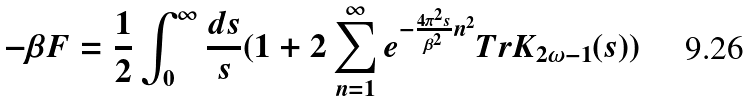Convert formula to latex. <formula><loc_0><loc_0><loc_500><loc_500>- \beta F = { \frac { 1 } { 2 } } \int _ { 0 } ^ { \infty } { \frac { d s } { s } } ( 1 + 2 \sum _ { n = 1 } ^ { \infty } e ^ { - { \frac { 4 \pi ^ { 2 } s } { \beta ^ { 2 } } } n ^ { 2 } } T r K _ { 2 \omega - 1 } ( s ) )</formula> 